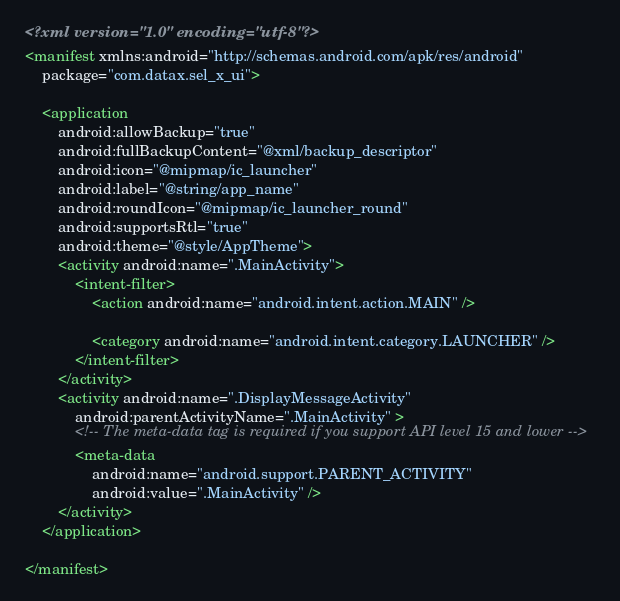<code> <loc_0><loc_0><loc_500><loc_500><_XML_><?xml version="1.0" encoding="utf-8"?>
<manifest xmlns:android="http://schemas.android.com/apk/res/android"
    package="com.datax.sel_x_ui">

    <application
        android:allowBackup="true"
        android:fullBackupContent="@xml/backup_descriptor"
        android:icon="@mipmap/ic_launcher"
        android:label="@string/app_name"
        android:roundIcon="@mipmap/ic_launcher_round"
        android:supportsRtl="true"
        android:theme="@style/AppTheme">
        <activity android:name=".MainActivity">
            <intent-filter>
                <action android:name="android.intent.action.MAIN" />

                <category android:name="android.intent.category.LAUNCHER" />
            </intent-filter>
        </activity>
        <activity android:name=".DisplayMessageActivity"
            android:parentActivityName=".MainActivity" >
            <!-- The meta-data tag is required if you support API level 15 and lower -->
            <meta-data
                android:name="android.support.PARENT_ACTIVITY"
                android:value=".MainActivity" />
        </activity>
    </application>

</manifest></code> 